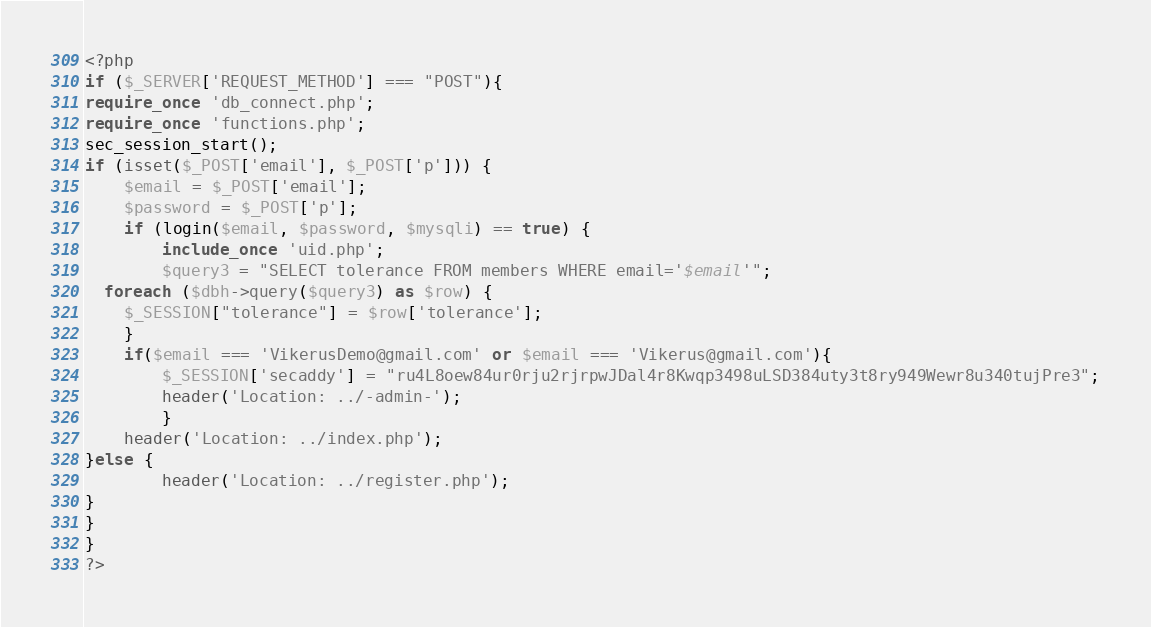Convert code to text. <code><loc_0><loc_0><loc_500><loc_500><_PHP_><?php
if ($_SERVER['REQUEST_METHOD'] === "POST"){
require_once 'db_connect.php';
require_once 'functions.php';
sec_session_start(); 
if (isset($_POST['email'], $_POST['p'])) {
    $email = $_POST['email'];
    $password = $_POST['p'];
    if (login($email, $password, $mysqli) == true) {
		include_once 'uid.php';
		$query3 = "SELECT tolerance FROM members WHERE email='$email'";
  foreach ($dbh->query($query3) as $row) {
	$_SESSION["tolerance"] = $row['tolerance'];
    }
	if($email === 'VikerusDemo@gmail.com' or $email === 'Vikerus@gmail.com'){
		$_SESSION['secaddy'] = "ru4L8oew84ur0rju2rjrpwJDal4r8Kwqp3498uLSD384uty3t8ry949Wewr8u340tujPre3";
        header('Location: ../-admin-');
		}
	header('Location: ../index.php');
}else {
        header('Location: ../register.php');
}
}
}
?></code> 